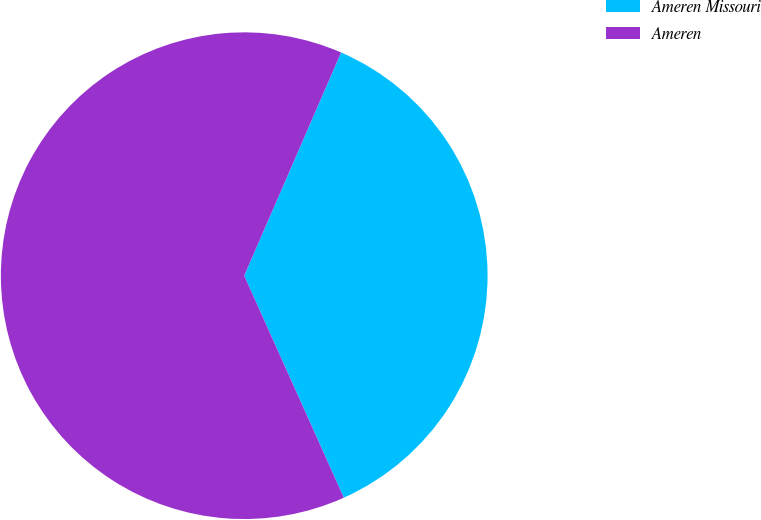Convert chart. <chart><loc_0><loc_0><loc_500><loc_500><pie_chart><fcel>Ameren Missouri<fcel>Ameren<nl><fcel>36.77%<fcel>63.23%<nl></chart> 